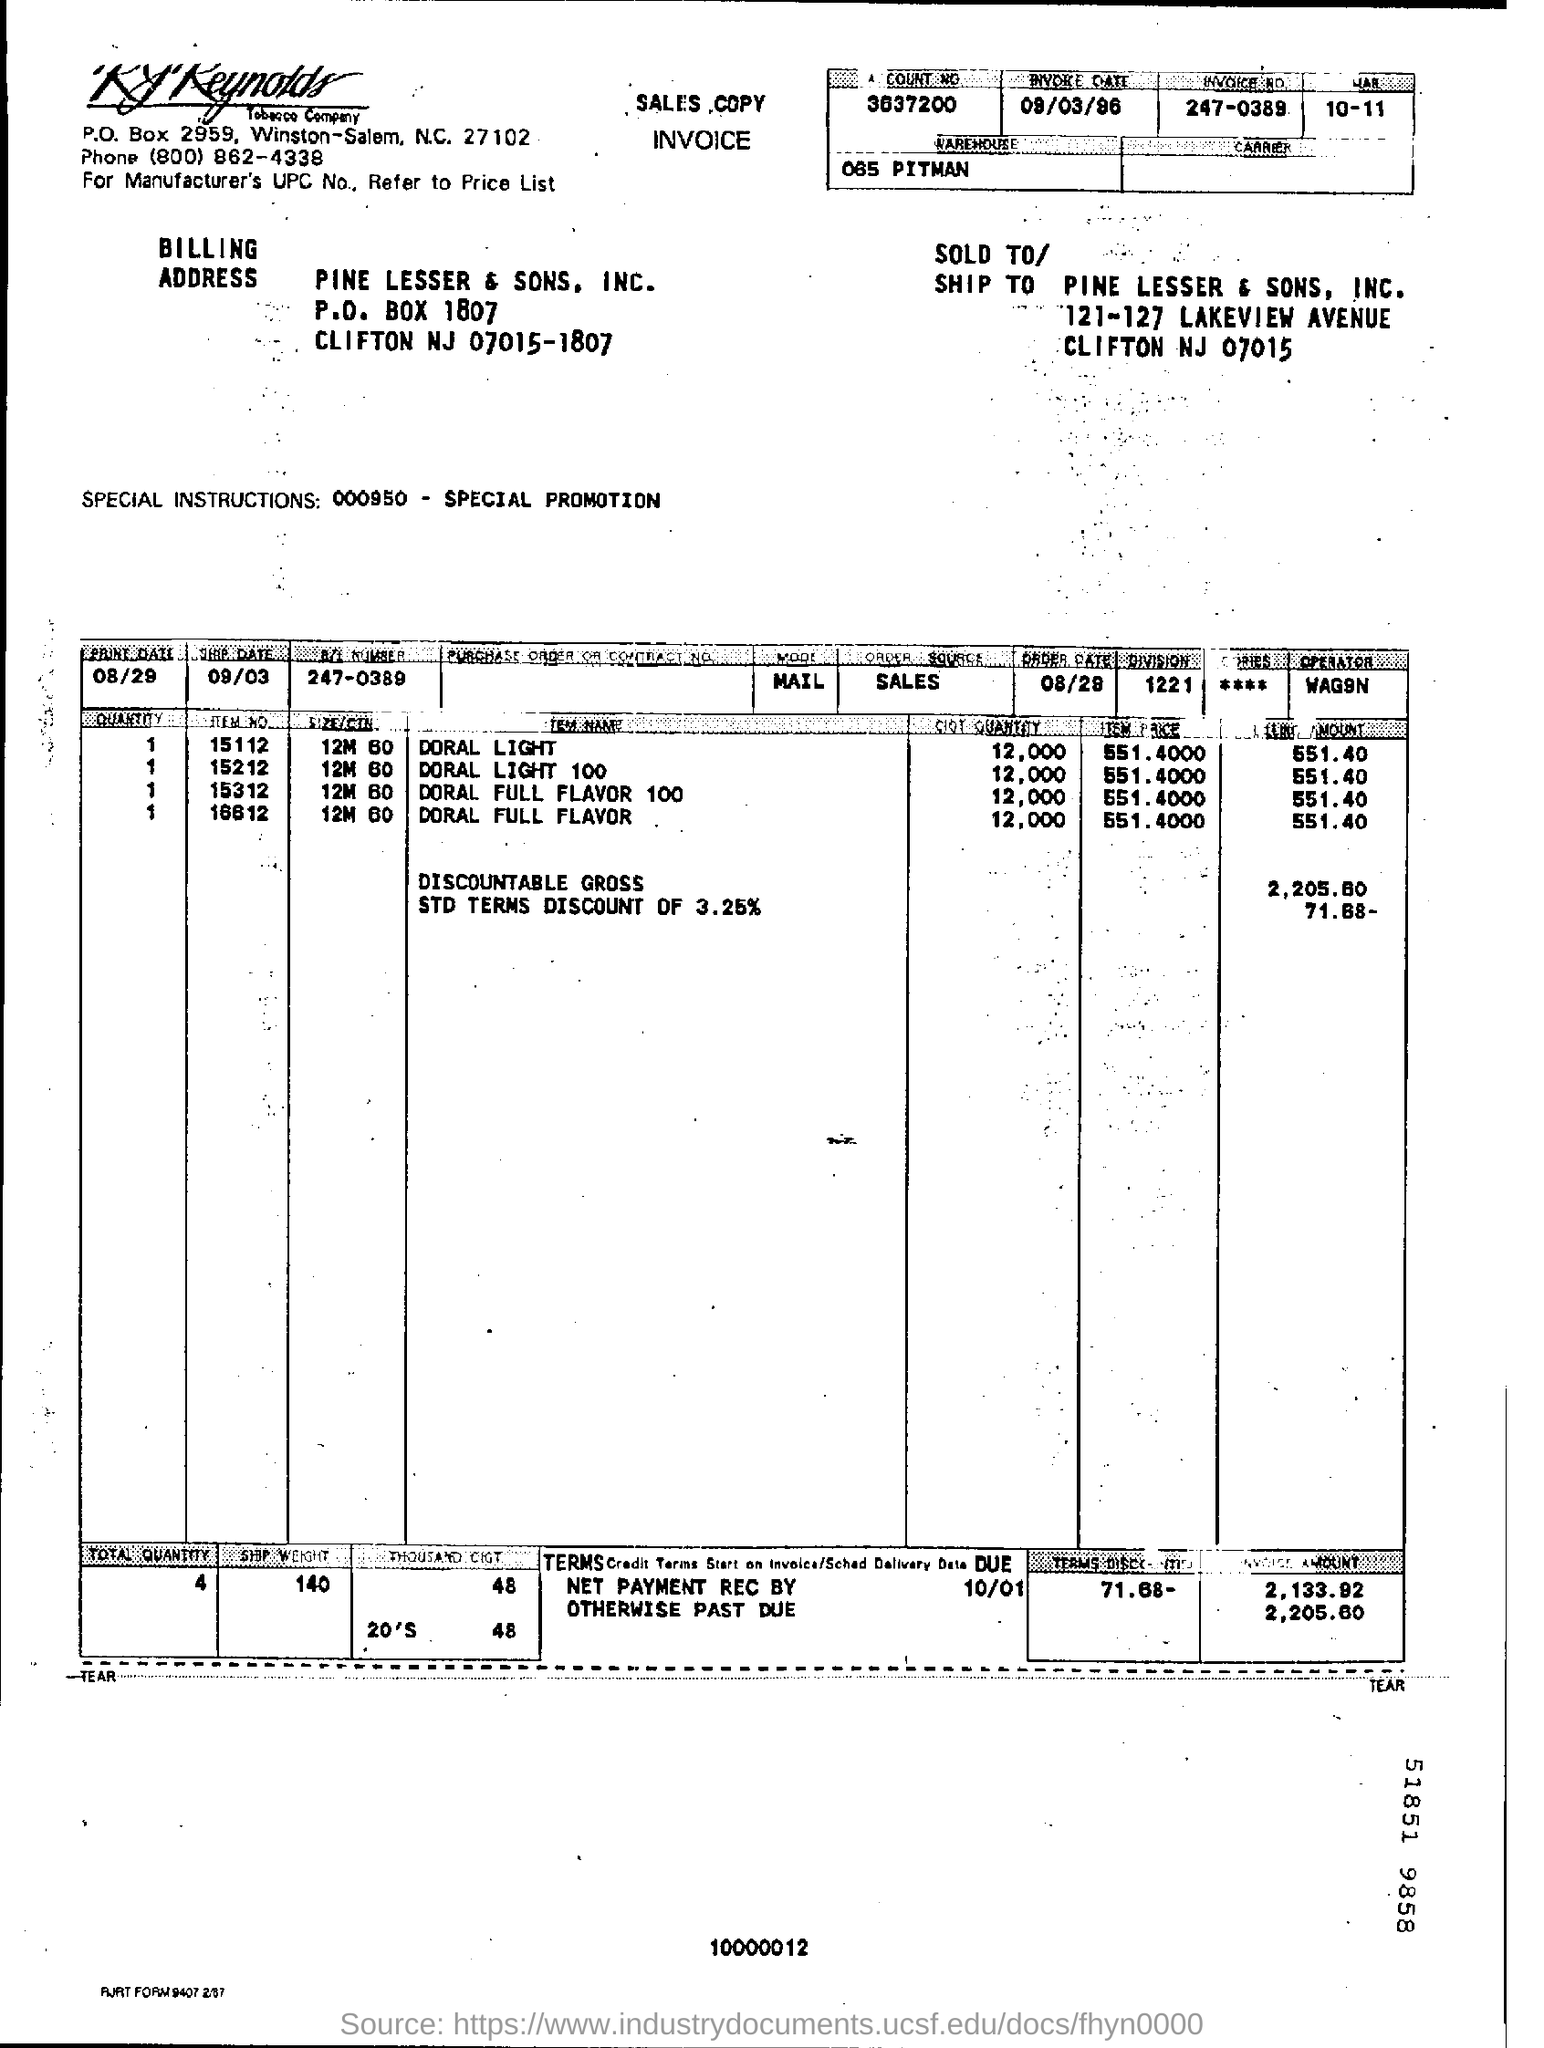What is the Invoice Date?
Provide a short and direct response. 09/03/96. What is the Invoice No. ?
Your answer should be very brief. 247-0389. What is the Discountable Gross?
Make the answer very short. 2,205.60. 